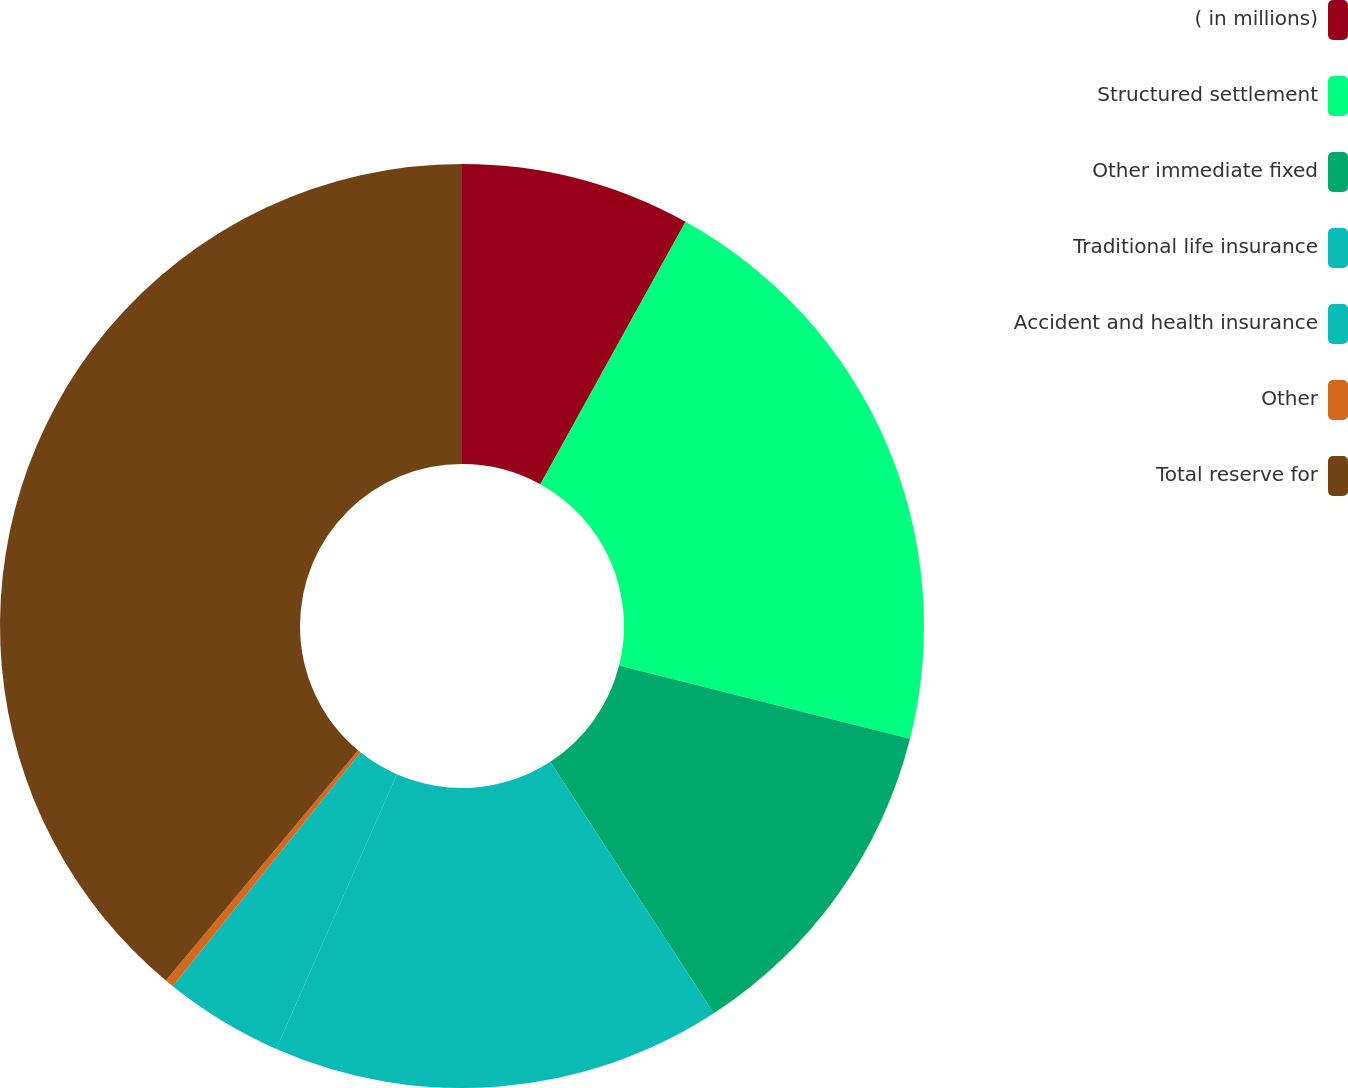<chart> <loc_0><loc_0><loc_500><loc_500><pie_chart><fcel>( in millions)<fcel>Structured settlement<fcel>Other immediate fixed<fcel>Traditional life insurance<fcel>Accident and health insurance<fcel>Other<fcel>Total reserve for<nl><fcel>8.04%<fcel>20.89%<fcel>11.9%<fcel>15.76%<fcel>4.18%<fcel>0.31%<fcel>38.93%<nl></chart> 